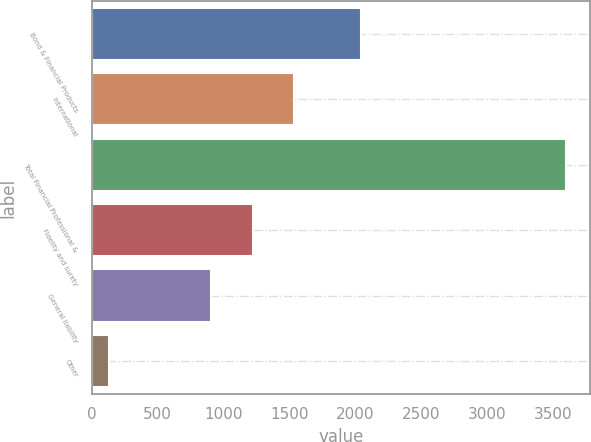Convert chart. <chart><loc_0><loc_0><loc_500><loc_500><bar_chart><fcel>Bond & Financial Products<fcel>International<fcel>Total Financial Professional &<fcel>Fidelity and surety<fcel>General liability<fcel>Other<nl><fcel>2040<fcel>1536.2<fcel>3600.1<fcel>1221.1<fcel>906<fcel>134<nl></chart> 